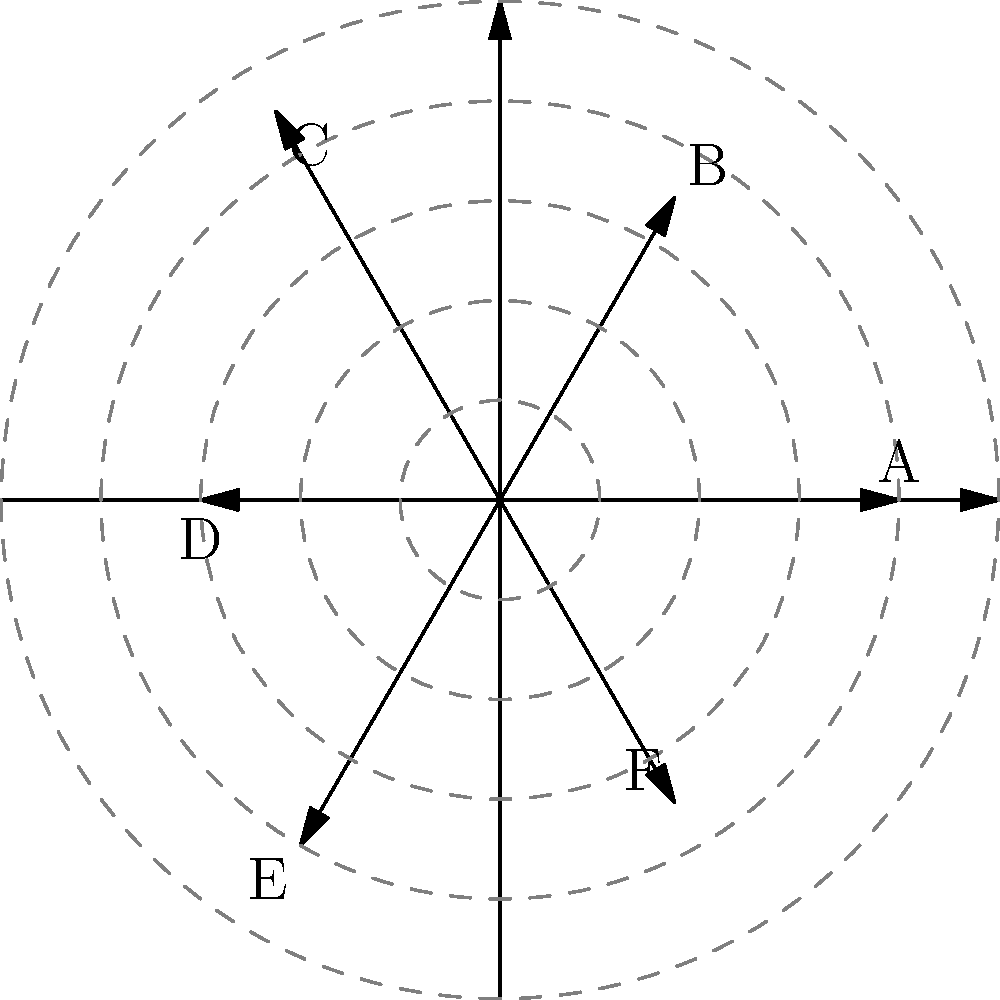As a pharmaceutical sales representative, you've collected customer satisfaction scores for six different medications (A to F) on a scale of 0 to 10. These scores are plotted on a polar coordinate system, where the angle represents the medication and the radius represents the satisfaction score. Given the polar plot, what is the average customer satisfaction score across all six medications? To find the average customer satisfaction score, we need to:

1. Identify the scores for each medication:
   A: 8
   B: 7
   C: 9
   D: 6
   E: 8
   F: 7

2. Sum up all the scores:
   $8 + 7 + 9 + 6 + 8 + 7 = 45$

3. Divide the sum by the number of medications (6) to get the average:
   $\frac{45}{6} = 7.5$

Therefore, the average customer satisfaction score across all six medications is 7.5.
Answer: 7.5 